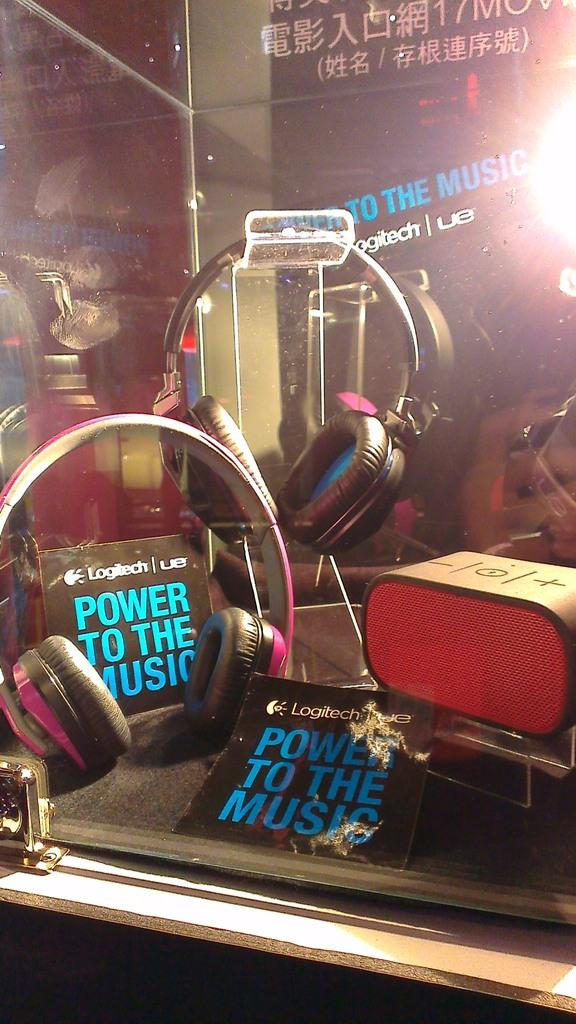What is located at the bottom of the image? There is a table at the bottom of the image. What items can be seen on the table? Headsets, a box, and papers are on the table. What can be seen in the background of the image? Boards, a wall, glass, and a light are visible in the background of the image. Can you see a stream flowing through the image? No, there is no stream visible in the image. What type of ice is being served in the lunchroom in the image? There is no lunchroom or ice present in the image. 